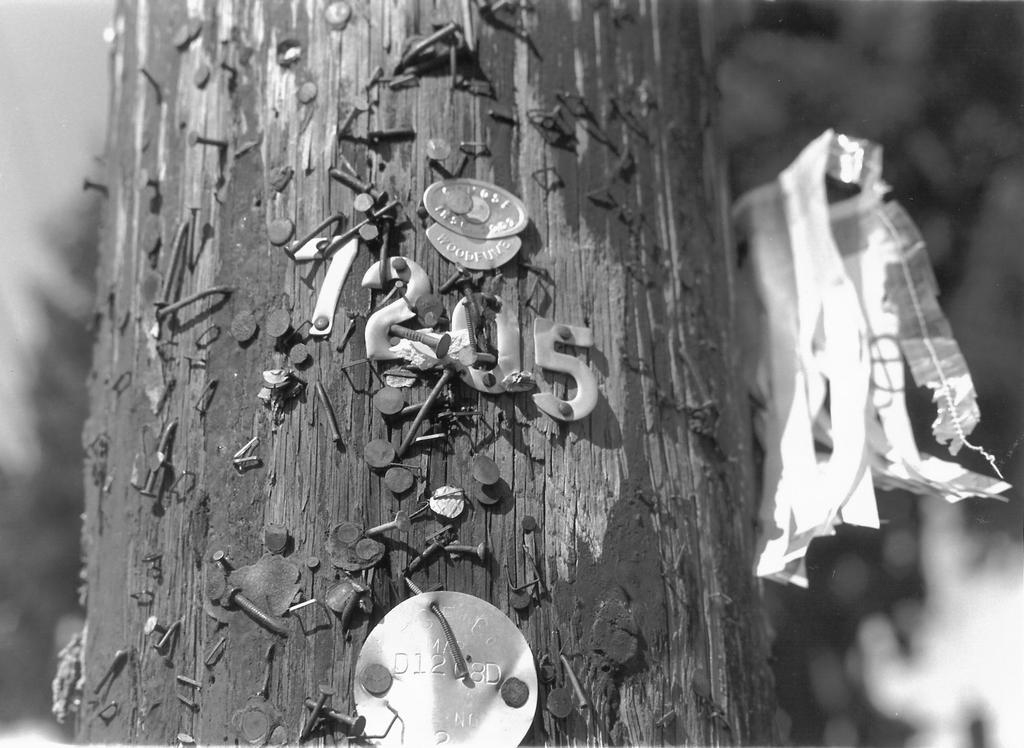Could you give a brief overview of what you see in this image? In the center of this picture we can see the bark of a tree and we can see the nails are hammered into the bark of a tree and we can see the numbers and some metal objects are hanging on the bark of a tree with the help of the nails. On the right we can see a plastic object seems to be hanging and we can see some other objects in the background. 